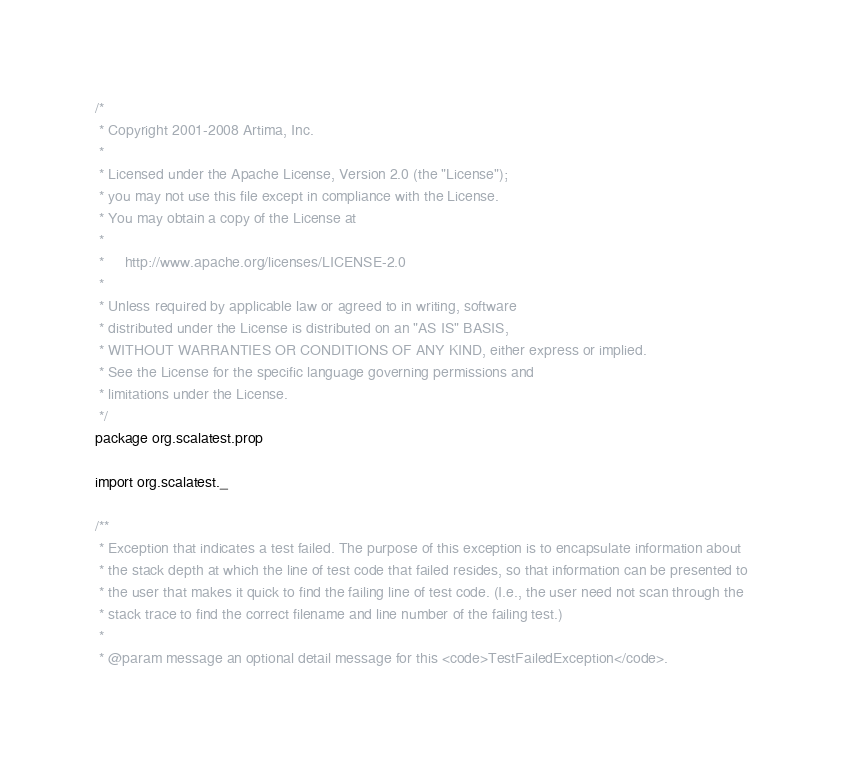Convert code to text. <code><loc_0><loc_0><loc_500><loc_500><_Scala_>/*
 * Copyright 2001-2008 Artima, Inc.
 *
 * Licensed under the Apache License, Version 2.0 (the "License");
 * you may not use this file except in compliance with the License.
 * You may obtain a copy of the License at
 *
 *     http://www.apache.org/licenses/LICENSE-2.0
 *
 * Unless required by applicable law or agreed to in writing, software
 * distributed under the License is distributed on an "AS IS" BASIS,
 * WITHOUT WARRANTIES OR CONDITIONS OF ANY KIND, either express or implied.
 * See the License for the specific language governing permissions and
 * limitations under the License.
 */
package org.scalatest.prop

import org.scalatest._

/**
 * Exception that indicates a test failed. The purpose of this exception is to encapsulate information about
 * the stack depth at which the line of test code that failed resides, so that information can be presented to
 * the user that makes it quick to find the failing line of test code. (I.e., the user need not scan through the
 * stack trace to find the correct filename and line number of the failing test.)
 *
 * @param message an optional detail message for this <code>TestFailedException</code>.</code> 